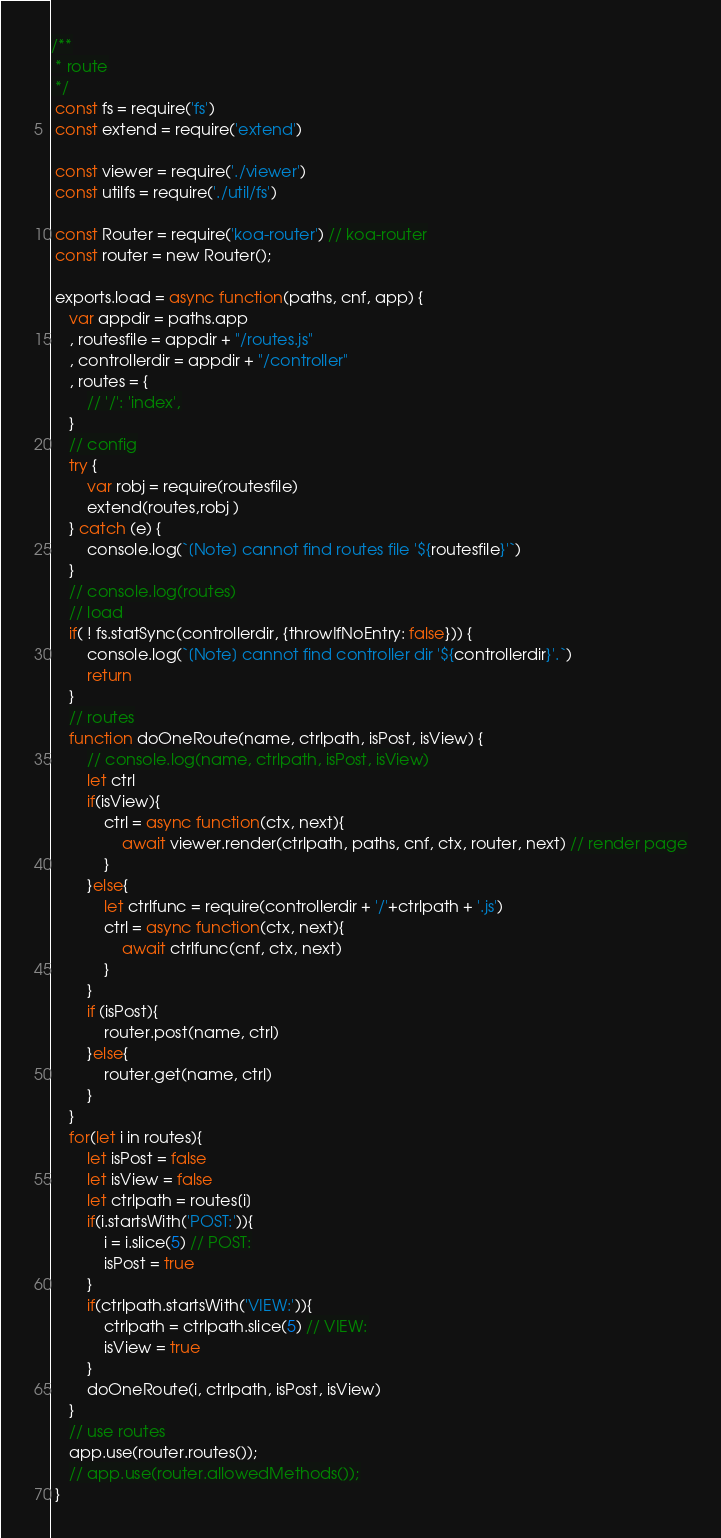<code> <loc_0><loc_0><loc_500><loc_500><_JavaScript_>/**
 * route
 */
 const fs = require('fs')
 const extend = require('extend')

 const viewer = require('./viewer')
 const utilfs = require('./util/fs')

 const Router = require('koa-router') // koa-router
 const router = new Router();

 exports.load = async function(paths, cnf, app) {
    var appdir = paths.app
    , routesfile = appdir + "/routes.js"
    , controllerdir = appdir + "/controller"
    , routes = {
        // '/': 'index',
    }
    // config
    try {
        var robj = require(routesfile)
        extend(routes,robj )
    } catch (e) {
        console.log(`[Note] cannot find routes file '${routesfile}'`)
    }
    // console.log(routes)
    // load
    if( ! fs.statSync(controllerdir, {throwIfNoEntry: false})) {
        console.log(`[Note] cannot find controller dir '${controllerdir}'.`)
        return
    }
    // routes
    function doOneRoute(name, ctrlpath, isPost, isView) {
        // console.log(name, ctrlpath, isPost, isView)
        let ctrl
        if(isView){
            ctrl = async function(ctx, next){
                await viewer.render(ctrlpath, paths, cnf, ctx, router, next) // render page
            }
        }else{
            let ctrlfunc = require(controllerdir + '/'+ctrlpath + '.js')
            ctrl = async function(ctx, next){
                await ctrlfunc(cnf, ctx, next)
            }
        }
        if (isPost){
            router.post(name, ctrl)
        }else{
            router.get(name, ctrl)
        }
    }
    for(let i in routes){
        let isPost = false
        let isView = false
        let ctrlpath = routes[i]
        if(i.startsWith('POST:')){
            i = i.slice(5) // POST:
            isPost = true
        }
        if(ctrlpath.startsWith('VIEW:')){
            ctrlpath = ctrlpath.slice(5) // VIEW:
            isView = true
        }
        doOneRoute(i, ctrlpath, isPost, isView)
    }
    // use routes
    app.use(router.routes());
    // app.use(router.allowedMethods());
 }
</code> 